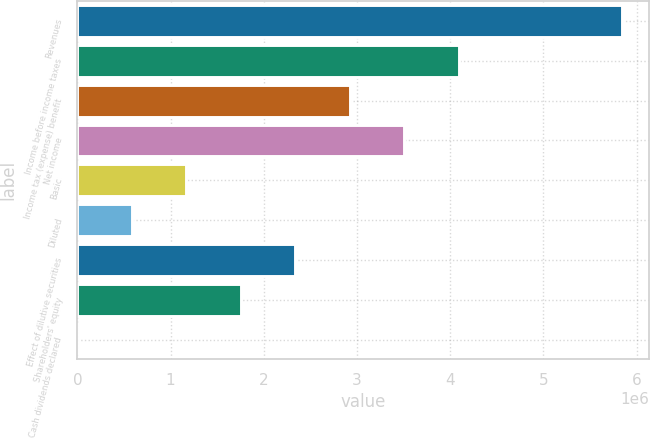Convert chart. <chart><loc_0><loc_0><loc_500><loc_500><bar_chart><fcel>Revenues<fcel>Income before income taxes<fcel>Income tax (expense) benefit<fcel>Net income<fcel>Basic<fcel>Diluted<fcel>Effect of dilutive securities<fcel>Shareholders' equity<fcel>Cash dividends declared<nl><fcel>5.84466e+06<fcel>4.09126e+06<fcel>2.92233e+06<fcel>3.50679e+06<fcel>1.16893e+06<fcel>584466<fcel>2.33786e+06<fcel>1.7534e+06<fcel>0.33<nl></chart> 